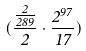<formula> <loc_0><loc_0><loc_500><loc_500>( \frac { \frac { 2 } { 2 8 9 } } { 2 } \cdot \frac { 2 ^ { 9 7 } } { 1 7 } )</formula> 